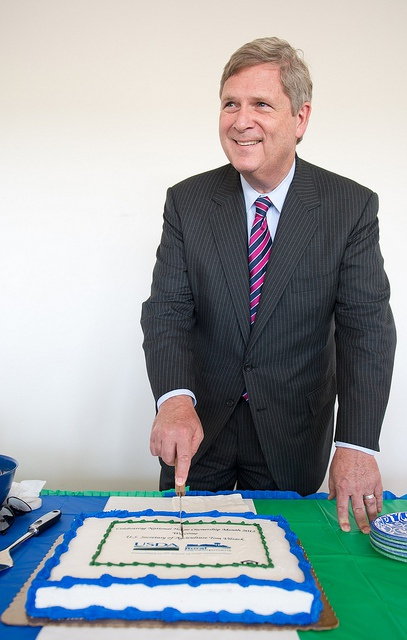Describe the objects in this image and their specific colors. I can see people in lightgray, black, gray, and lightpink tones, dining table in lightgray, green, and blue tones, cake in lightgray, blue, and darkgray tones, tie in lightgray, navy, magenta, darkblue, and purple tones, and knife in lightgray, gray, tan, and darkgray tones in this image. 